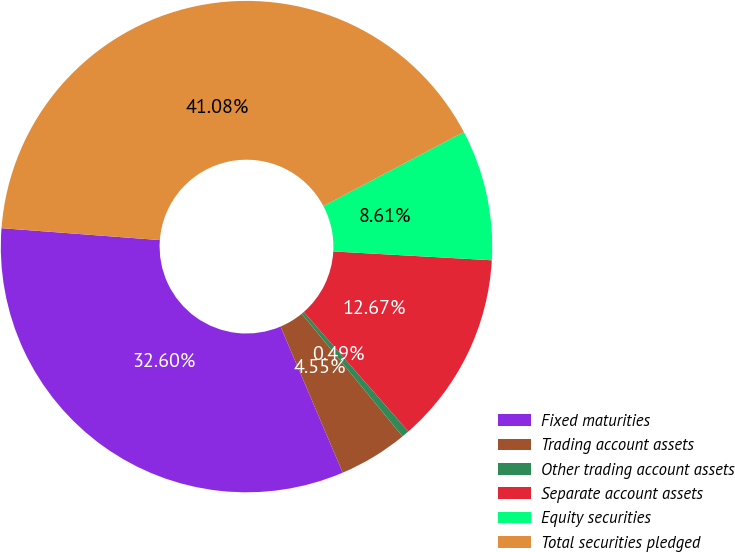Convert chart to OTSL. <chart><loc_0><loc_0><loc_500><loc_500><pie_chart><fcel>Fixed maturities<fcel>Trading account assets<fcel>Other trading account assets<fcel>Separate account assets<fcel>Equity securities<fcel>Total securities pledged<nl><fcel>32.6%<fcel>4.55%<fcel>0.49%<fcel>12.67%<fcel>8.61%<fcel>41.08%<nl></chart> 